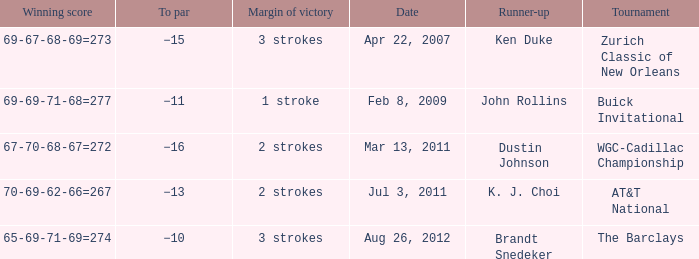What was the margin of victory when Brandt Snedeker was runner-up? 3 strokes. 